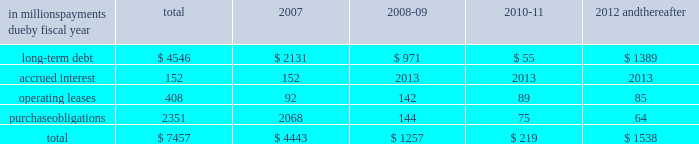Guarantees to third parties .
We have , however , issued guar- antees and comfort letters of $ 171 million for the debt and other obligations of unconsolidated affiliates , primarily for cpw .
In addition , off-balance sheet arrangements are gener- ally limited to the future payments under noncancelable operating leases , which totaled $ 408 million at may 28 , at may 28 , 2006 , we had invested in four variable interest entities ( vies ) .
We are the primary beneficiary ( pb ) of general mills capital , inc .
( gm capital ) , a subsidiary that we consolidate as set forth in note eight to the consoli- dated financial statements appearing on pages 43 and 44 in item eight of this report .
We also have an interest in a contract manufacturer at our former facility in geneva , illi- nois .
Even though we are the pb , we have not consolidated this entity because it is not material to our results of oper- ations , financial condition , or liquidity at may 28 , 2006 .
This entity had property and equipment of $ 50 million and long-term debt of $ 50 million at may 28 , 2006 .
We are not the pb of the remaining two vies .
Our maximum exposure to loss from these vies is limited to the $ 150 million minority interest in gm capital , the contract manufactur- er 2019s debt and our $ 6 million of equity investments in the two remaining vies .
The table summarizes our future estimated cash payments under existing contractual obligations , including payments due by period .
The majority of the purchase obligations represent commitments for raw mate- rial and packaging to be utilized in the normal course of business and for consumer-directed marketing commit- ments that support our brands .
The net fair value of our interest rate and equity swaps was $ 159 million at may 28 , 2006 , based on market values as of that date .
Future changes in market values will impact the amount of cash ultimately paid or received to settle those instruments in the future .
Other long-term obligations primarily consist of income taxes , accrued compensation and benefits , and miscella- neous liabilities .
We are unable to estimate the timing of the payments for these items .
We do not have significant statutory or contractual funding requirements for our defined-benefit retirement and other postretirement benefit plans .
Further information on these plans , including our expected contributions for fiscal 2007 , is set forth in note thirteen to the consolidated financial statements appearing on pages 47 through 50 in item eight of this report .
In millions , payments due by fiscal year total 2007 2008-09 2010-11 2012 and thereafter .
Significant accounting estimates for a complete description of our significant accounting policies , please see note one to the consolidated financial statements appearing on pages 35 through 37 in item eight of this report .
Our significant accounting estimates are those that have meaningful impact on the reporting of our financial condition and results of operations .
These poli- cies include our accounting for trade and consumer promotion activities ; goodwill and other intangible asset impairments ; income taxes ; and pension and other postretirement benefits .
Trade and consumer promotion activities we report sales net of certain coupon and trade promotion costs .
The consumer coupon costs recorded as a reduction of sales are based on the estimated redemption value of those coupons , as determined by historical patterns of coupon redemption and consideration of current market conditions such as competitive activity in those product categories .
The trade promotion costs include payments to customers to perform merchandising activities on our behalf , such as advertising or in-store displays , discounts to our list prices to lower retail shelf prices , and payments to gain distribution of new products .
The cost of these activi- ties is recognized as the related revenue is recorded , which generally precedes the actual cash expenditure .
The recog- nition of these costs requires estimation of customer participation and performance levels .
These estimates are made based on the quantity of customer sales , the timing and forecasted costs of promotional activities , and other factors .
Differences between estimated expenses and actual costs are normally insignificant and are recognized as a change in management estimate in a subsequent period .
Our accrued trade and consumer promotion liability was $ 339 million as of may 28 , 2006 , and $ 283 million as of may 29 , 2005 .
Our unit volume in the last week of each quarter is consis- tently higher than the average for the preceding weeks of the quarter .
In comparison to the average daily shipments in the first 12 weeks of a quarter , the final week of each quarter has approximately two to four days 2019 worth of incre- mental shipments ( based on a five-day week ) , reflecting increased promotional activity at the end of the quarter .
This increased activity includes promotions to assure that our customers have sufficient inventory on hand to support major marketing events or increased seasonal demand early in the next quarter , as well as promotions intended to help achieve interim unit volume targets .
If , due to quarter-end promotions or other reasons , our customers purchase more product in any reporting period than end-consumer demand will require in future periods , our sales level in future reporting periods could be adversely affected. .
What portion of the total obligations are due by fiscal year 2007? 
Computations: (4443 / 7457)
Answer: 0.59582. 